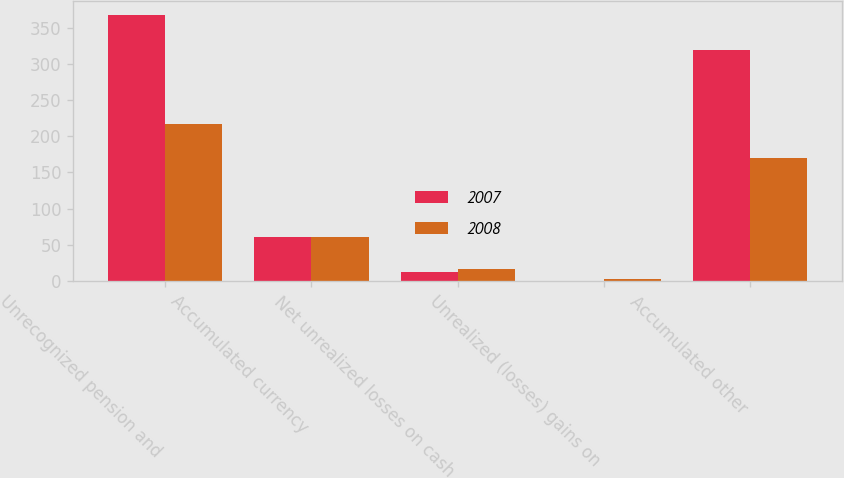Convert chart. <chart><loc_0><loc_0><loc_500><loc_500><stacked_bar_chart><ecel><fcel>Unrecognized pension and<fcel>Accumulated currency<fcel>Net unrealized losses on cash<fcel>Unrealized (losses) gains on<fcel>Accumulated other<nl><fcel>2007<fcel>368<fcel>60.9<fcel>11.8<fcel>0.1<fcel>319<nl><fcel>2008<fcel>216.7<fcel>61.2<fcel>16.7<fcel>2.5<fcel>169.7<nl></chart> 